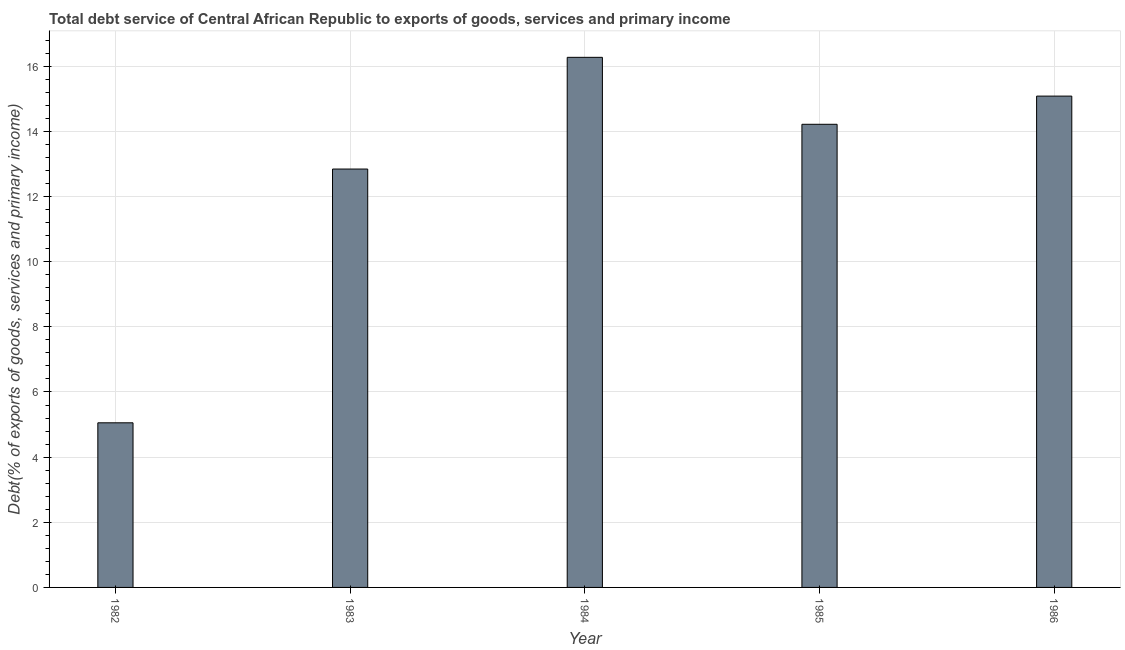Does the graph contain grids?
Provide a succinct answer. Yes. What is the title of the graph?
Offer a terse response. Total debt service of Central African Republic to exports of goods, services and primary income. What is the label or title of the X-axis?
Offer a terse response. Year. What is the label or title of the Y-axis?
Your response must be concise. Debt(% of exports of goods, services and primary income). What is the total debt service in 1985?
Give a very brief answer. 14.22. Across all years, what is the maximum total debt service?
Your answer should be very brief. 16.27. Across all years, what is the minimum total debt service?
Provide a short and direct response. 5.05. What is the sum of the total debt service?
Provide a succinct answer. 63.48. What is the difference between the total debt service in 1982 and 1984?
Provide a short and direct response. -11.22. What is the average total debt service per year?
Offer a very short reply. 12.7. What is the median total debt service?
Offer a very short reply. 14.22. In how many years, is the total debt service greater than 13.2 %?
Your answer should be compact. 3. Do a majority of the years between 1982 and 1983 (inclusive) have total debt service greater than 14 %?
Make the answer very short. No. What is the ratio of the total debt service in 1982 to that in 1984?
Your answer should be compact. 0.31. Is the total debt service in 1982 less than that in 1986?
Provide a short and direct response. Yes. Is the difference between the total debt service in 1984 and 1986 greater than the difference between any two years?
Offer a terse response. No. What is the difference between the highest and the second highest total debt service?
Provide a short and direct response. 1.19. What is the difference between the highest and the lowest total debt service?
Give a very brief answer. 11.22. In how many years, is the total debt service greater than the average total debt service taken over all years?
Keep it short and to the point. 4. How many bars are there?
Offer a terse response. 5. Are all the bars in the graph horizontal?
Keep it short and to the point. No. What is the Debt(% of exports of goods, services and primary income) of 1982?
Your answer should be very brief. 5.05. What is the Debt(% of exports of goods, services and primary income) of 1983?
Provide a succinct answer. 12.84. What is the Debt(% of exports of goods, services and primary income) of 1984?
Make the answer very short. 16.27. What is the Debt(% of exports of goods, services and primary income) of 1985?
Your answer should be very brief. 14.22. What is the Debt(% of exports of goods, services and primary income) of 1986?
Offer a terse response. 15.08. What is the difference between the Debt(% of exports of goods, services and primary income) in 1982 and 1983?
Make the answer very short. -7.79. What is the difference between the Debt(% of exports of goods, services and primary income) in 1982 and 1984?
Ensure brevity in your answer.  -11.22. What is the difference between the Debt(% of exports of goods, services and primary income) in 1982 and 1985?
Give a very brief answer. -9.16. What is the difference between the Debt(% of exports of goods, services and primary income) in 1982 and 1986?
Your answer should be compact. -10.03. What is the difference between the Debt(% of exports of goods, services and primary income) in 1983 and 1984?
Make the answer very short. -3.43. What is the difference between the Debt(% of exports of goods, services and primary income) in 1983 and 1985?
Make the answer very short. -1.37. What is the difference between the Debt(% of exports of goods, services and primary income) in 1983 and 1986?
Offer a terse response. -2.24. What is the difference between the Debt(% of exports of goods, services and primary income) in 1984 and 1985?
Provide a short and direct response. 2.06. What is the difference between the Debt(% of exports of goods, services and primary income) in 1984 and 1986?
Your answer should be very brief. 1.19. What is the difference between the Debt(% of exports of goods, services and primary income) in 1985 and 1986?
Your answer should be very brief. -0.87. What is the ratio of the Debt(% of exports of goods, services and primary income) in 1982 to that in 1983?
Your answer should be compact. 0.39. What is the ratio of the Debt(% of exports of goods, services and primary income) in 1982 to that in 1984?
Provide a succinct answer. 0.31. What is the ratio of the Debt(% of exports of goods, services and primary income) in 1982 to that in 1985?
Your answer should be compact. 0.35. What is the ratio of the Debt(% of exports of goods, services and primary income) in 1982 to that in 1986?
Provide a succinct answer. 0.34. What is the ratio of the Debt(% of exports of goods, services and primary income) in 1983 to that in 1984?
Offer a terse response. 0.79. What is the ratio of the Debt(% of exports of goods, services and primary income) in 1983 to that in 1985?
Give a very brief answer. 0.9. What is the ratio of the Debt(% of exports of goods, services and primary income) in 1983 to that in 1986?
Provide a succinct answer. 0.85. What is the ratio of the Debt(% of exports of goods, services and primary income) in 1984 to that in 1985?
Your response must be concise. 1.15. What is the ratio of the Debt(% of exports of goods, services and primary income) in 1984 to that in 1986?
Your answer should be very brief. 1.08. What is the ratio of the Debt(% of exports of goods, services and primary income) in 1985 to that in 1986?
Provide a succinct answer. 0.94. 